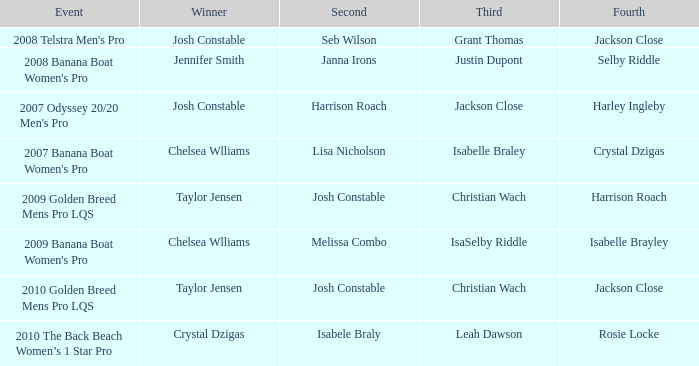Would you be able to parse every entry in this table? {'header': ['Event', 'Winner', 'Second', 'Third', 'Fourth'], 'rows': [["2008 Telstra Men's Pro", 'Josh Constable', 'Seb Wilson', 'Grant Thomas', 'Jackson Close'], ["2008 Banana Boat Women's Pro", 'Jennifer Smith', 'Janna Irons', 'Justin Dupont', 'Selby Riddle'], ["2007 Odyssey 20/20 Men's Pro", 'Josh Constable', 'Harrison Roach', 'Jackson Close', 'Harley Ingleby'], ["2007 Banana Boat Women's Pro", 'Chelsea Wlliams', 'Lisa Nicholson', 'Isabelle Braley', 'Crystal Dzigas'], ['2009 Golden Breed Mens Pro LQS', 'Taylor Jensen', 'Josh Constable', 'Christian Wach', 'Harrison Roach'], ["2009 Banana Boat Women's Pro", 'Chelsea Wlliams', 'Melissa Combo', 'IsaSelby Riddle', 'Isabelle Brayley'], ['2010 Golden Breed Mens Pro LQS', 'Taylor Jensen', 'Josh Constable', 'Christian Wach', 'Jackson Close'], ['2010 The Back Beach Women’s 1 Star Pro', 'Crystal Dzigas', 'Isabele Braly', 'Leah Dawson', 'Rosie Locke']]} Who was the Winner when Selby Riddle came in Fourth? Jennifer Smith. 